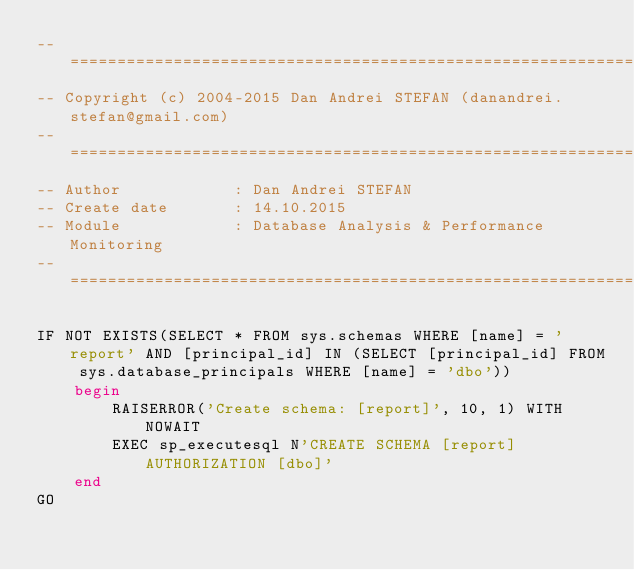Convert code to text. <code><loc_0><loc_0><loc_500><loc_500><_SQL_>-- ============================================================================
-- Copyright (c) 2004-2015 Dan Andrei STEFAN (danandrei.stefan@gmail.com)
-- ============================================================================
-- Author			 : Dan Andrei STEFAN
-- Create date		 : 14.10.2015
-- Module			 : Database Analysis & Performance Monitoring
-- ============================================================================

IF NOT EXISTS(SELECT * FROM sys.schemas WHERE [name] = 'report' AND [principal_id] IN (SELECT [principal_id] FROM sys.database_principals WHERE [name] = 'dbo'))
	begin
		RAISERROR('Create schema: [report]', 10, 1) WITH NOWAIT
		EXEC sp_executesql N'CREATE SCHEMA [report] AUTHORIZATION [dbo]'
	end
GO
</code> 